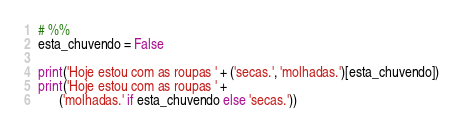<code> <loc_0><loc_0><loc_500><loc_500><_Python_># %%
esta_chuvendo = False

print('Hoje estou com as roupas ' + ('secas.', 'molhadas.')[esta_chuvendo])
print('Hoje estou com as roupas ' + 
      ('molhadas.' if esta_chuvendo else 'secas.'))
</code> 